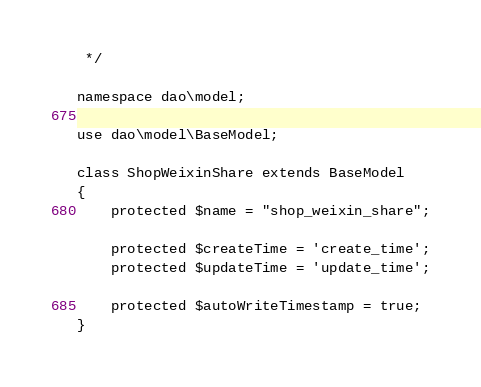<code> <loc_0><loc_0><loc_500><loc_500><_PHP_> */

namespace dao\model;

use dao\model\BaseModel;

class ShopWeixinShare extends BaseModel
{
    protected $name = "shop_weixin_share";

    protected $createTime = 'create_time';
    protected $updateTime = 'update_time';

    protected $autoWriteTimestamp = true;
}
</code> 